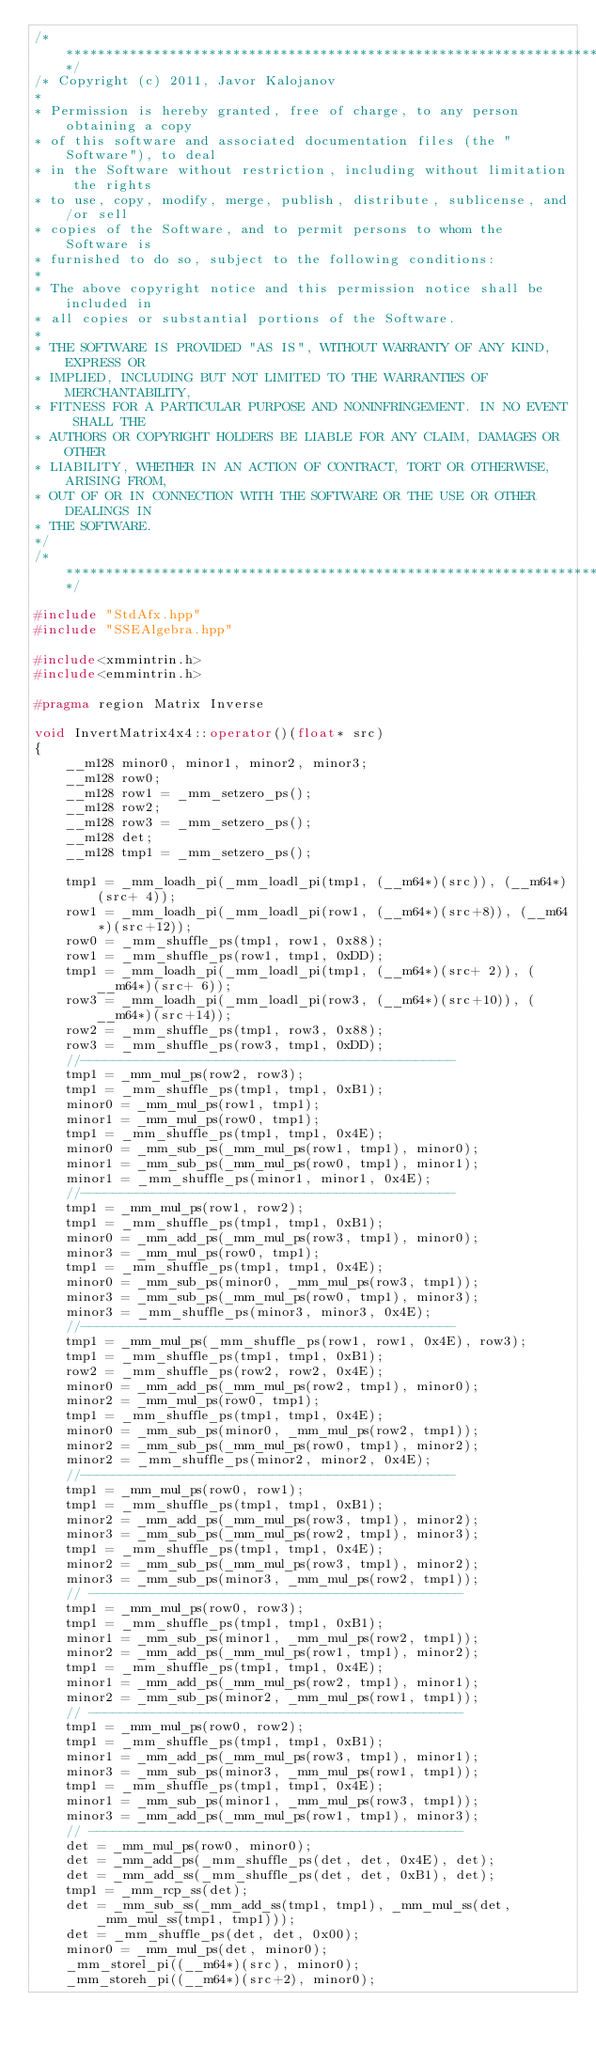<code> <loc_0><loc_0><loc_500><loc_500><_C++_>/****************************************************************************/
/* Copyright (c) 2011, Javor Kalojanov
* 
* Permission is hereby granted, free of charge, to any person obtaining a copy
* of this software and associated documentation files (the "Software"), to deal
* in the Software without restriction, including without limitation the rights
* to use, copy, modify, merge, publish, distribute, sublicense, and/or sell
* copies of the Software, and to permit persons to whom the Software is
* furnished to do so, subject to the following conditions:
* 
* The above copyright notice and this permission notice shall be included in
* all copies or substantial portions of the Software.
* 
* THE SOFTWARE IS PROVIDED "AS IS", WITHOUT WARRANTY OF ANY KIND, EXPRESS OR
* IMPLIED, INCLUDING BUT NOT LIMITED TO THE WARRANTIES OF MERCHANTABILITY,
* FITNESS FOR A PARTICULAR PURPOSE AND NONINFRINGEMENT. IN NO EVENT SHALL THE
* AUTHORS OR COPYRIGHT HOLDERS BE LIABLE FOR ANY CLAIM, DAMAGES OR OTHER
* LIABILITY, WHETHER IN AN ACTION OF CONTRACT, TORT OR OTHERWISE, ARISING FROM,
* OUT OF OR IN CONNECTION WITH THE SOFTWARE OR THE USE OR OTHER DEALINGS IN
* THE SOFTWARE.
*/
/****************************************************************************/

#include "StdAfx.hpp"
#include "SSEAlgebra.hpp"

#include<xmmintrin.h>
#include<emmintrin.h>

#pragma region Matrix Inverse

void InvertMatrix4x4::operator()(float* src)
{
    __m128 minor0, minor1, minor2, minor3;
    __m128 row0;
    __m128 row1 = _mm_setzero_ps();
    __m128 row2;
    __m128 row3 = _mm_setzero_ps();
    __m128 det;
    __m128 tmp1 = _mm_setzero_ps();

    tmp1 = _mm_loadh_pi(_mm_loadl_pi(tmp1, (__m64*)(src)), (__m64*)(src+ 4));
    row1 = _mm_loadh_pi(_mm_loadl_pi(row1, (__m64*)(src+8)), (__m64*)(src+12));
    row0 = _mm_shuffle_ps(tmp1, row1, 0x88);
    row1 = _mm_shuffle_ps(row1, tmp1, 0xDD);
    tmp1 = _mm_loadh_pi(_mm_loadl_pi(tmp1, (__m64*)(src+ 2)), (__m64*)(src+ 6));
    row3 = _mm_loadh_pi(_mm_loadl_pi(row3, (__m64*)(src+10)), (__m64*)(src+14));
    row2 = _mm_shuffle_ps(tmp1, row3, 0x88);
    row3 = _mm_shuffle_ps(row3, tmp1, 0xDD);
    //-----------------------------------------------
    tmp1 = _mm_mul_ps(row2, row3);
    tmp1 = _mm_shuffle_ps(tmp1, tmp1, 0xB1);
    minor0 = _mm_mul_ps(row1, tmp1);
    minor1 = _mm_mul_ps(row0, tmp1);
    tmp1 = _mm_shuffle_ps(tmp1, tmp1, 0x4E);
    minor0 = _mm_sub_ps(_mm_mul_ps(row1, tmp1), minor0);
    minor1 = _mm_sub_ps(_mm_mul_ps(row0, tmp1), minor1);
    minor1 = _mm_shuffle_ps(minor1, minor1, 0x4E);
    //-----------------------------------------------
    tmp1 = _mm_mul_ps(row1, row2);
    tmp1 = _mm_shuffle_ps(tmp1, tmp1, 0xB1);
    minor0 = _mm_add_ps(_mm_mul_ps(row3, tmp1), minor0);
    minor3 = _mm_mul_ps(row0, tmp1);
    tmp1 = _mm_shuffle_ps(tmp1, tmp1, 0x4E);
    minor0 = _mm_sub_ps(minor0, _mm_mul_ps(row3, tmp1));
    minor3 = _mm_sub_ps(_mm_mul_ps(row0, tmp1), minor3);
    minor3 = _mm_shuffle_ps(minor3, minor3, 0x4E);
    //-----------------------------------------------
    tmp1 = _mm_mul_ps(_mm_shuffle_ps(row1, row1, 0x4E), row3);
    tmp1 = _mm_shuffle_ps(tmp1, tmp1, 0xB1);
    row2 = _mm_shuffle_ps(row2, row2, 0x4E);
    minor0 = _mm_add_ps(_mm_mul_ps(row2, tmp1), minor0);
    minor2 = _mm_mul_ps(row0, tmp1);
    tmp1 = _mm_shuffle_ps(tmp1, tmp1, 0x4E);
    minor0 = _mm_sub_ps(minor0, _mm_mul_ps(row2, tmp1));
    minor2 = _mm_sub_ps(_mm_mul_ps(row0, tmp1), minor2);
    minor2 = _mm_shuffle_ps(minor2, minor2, 0x4E);
    //-----------------------------------------------
    tmp1 = _mm_mul_ps(row0, row1);
    tmp1 = _mm_shuffle_ps(tmp1, tmp1, 0xB1);
    minor2 = _mm_add_ps(_mm_mul_ps(row3, tmp1), minor2);
    minor3 = _mm_sub_ps(_mm_mul_ps(row2, tmp1), minor3);
    tmp1 = _mm_shuffle_ps(tmp1, tmp1, 0x4E);
    minor2 = _mm_sub_ps(_mm_mul_ps(row3, tmp1), minor2);
    minor3 = _mm_sub_ps(minor3, _mm_mul_ps(row2, tmp1));
    // -----------------------------------------------
    tmp1 = _mm_mul_ps(row0, row3);
    tmp1 = _mm_shuffle_ps(tmp1, tmp1, 0xB1);
    minor1 = _mm_sub_ps(minor1, _mm_mul_ps(row2, tmp1));
    minor2 = _mm_add_ps(_mm_mul_ps(row1, tmp1), minor2);
    tmp1 = _mm_shuffle_ps(tmp1, tmp1, 0x4E);
    minor1 = _mm_add_ps(_mm_mul_ps(row2, tmp1), minor1);
    minor2 = _mm_sub_ps(minor2, _mm_mul_ps(row1, tmp1));
    // -----------------------------------------------
    tmp1 = _mm_mul_ps(row0, row2);
    tmp1 = _mm_shuffle_ps(tmp1, tmp1, 0xB1);
    minor1 = _mm_add_ps(_mm_mul_ps(row3, tmp1), minor1);
    minor3 = _mm_sub_ps(minor3, _mm_mul_ps(row1, tmp1));
    tmp1 = _mm_shuffle_ps(tmp1, tmp1, 0x4E);
    minor1 = _mm_sub_ps(minor1, _mm_mul_ps(row3, tmp1));
    minor3 = _mm_add_ps(_mm_mul_ps(row1, tmp1), minor3);
    // -----------------------------------------------
    det = _mm_mul_ps(row0, minor0);
    det = _mm_add_ps(_mm_shuffle_ps(det, det, 0x4E), det);
    det = _mm_add_ss(_mm_shuffle_ps(det, det, 0xB1), det);
    tmp1 = _mm_rcp_ss(det);
    det = _mm_sub_ss(_mm_add_ss(tmp1, tmp1), _mm_mul_ss(det, _mm_mul_ss(tmp1, tmp1)));
    det = _mm_shuffle_ps(det, det, 0x00);
    minor0 = _mm_mul_ps(det, minor0);
    _mm_storel_pi((__m64*)(src), minor0);
    _mm_storeh_pi((__m64*)(src+2), minor0);</code> 